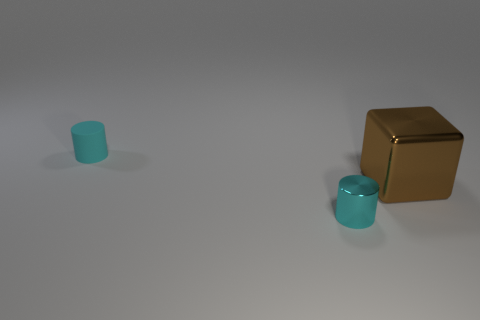Add 2 small red metallic things. How many objects exist? 5 Subtract all cylinders. How many objects are left? 1 Add 2 big blocks. How many big blocks exist? 3 Subtract 0 blue cylinders. How many objects are left? 3 Subtract all big red shiny things. Subtract all big brown blocks. How many objects are left? 2 Add 3 small shiny cylinders. How many small shiny cylinders are left? 4 